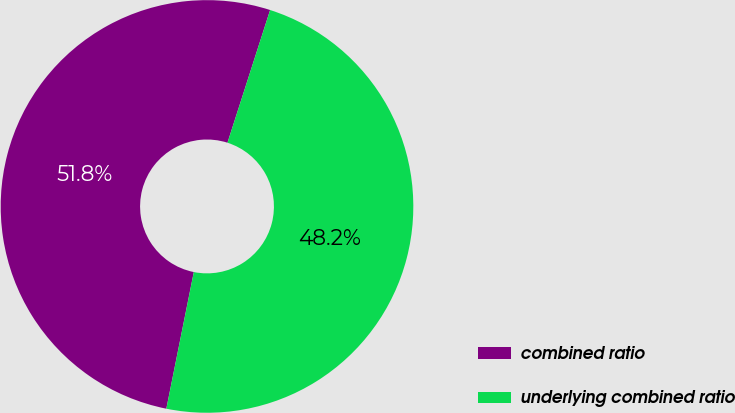Convert chart to OTSL. <chart><loc_0><loc_0><loc_500><loc_500><pie_chart><fcel>combined ratio<fcel>underlying combined ratio<nl><fcel>51.79%<fcel>48.21%<nl></chart> 